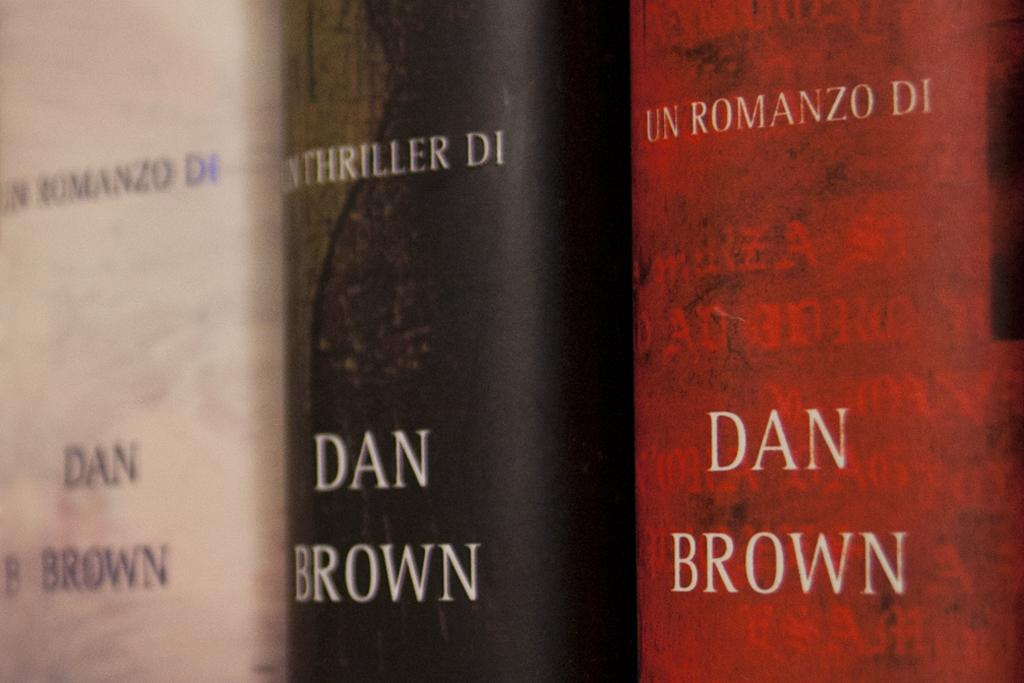<image>
Give a short and clear explanation of the subsequent image. White, black, and red books by Dan Brown next to one another. 